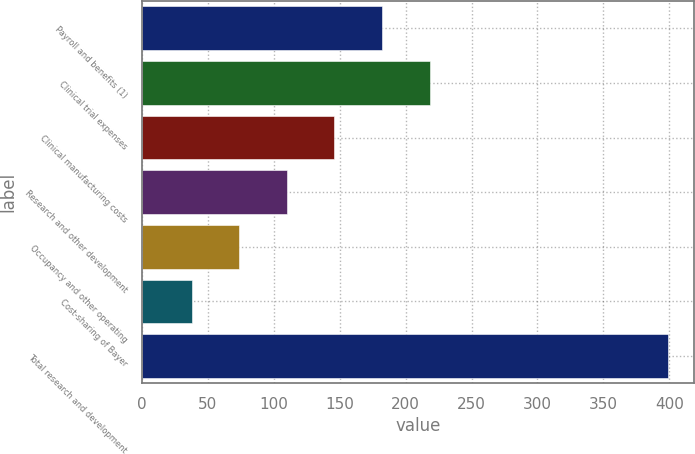Convert chart. <chart><loc_0><loc_0><loc_500><loc_500><bar_chart><fcel>Payroll and benefits (1)<fcel>Clinical trial expenses<fcel>Clinical manufacturing costs<fcel>Research and other development<fcel>Occupancy and other operating<fcel>Cost-sharing of Bayer<fcel>Total research and development<nl><fcel>182.14<fcel>218.25<fcel>146.03<fcel>109.92<fcel>73.81<fcel>37.7<fcel>398.8<nl></chart> 